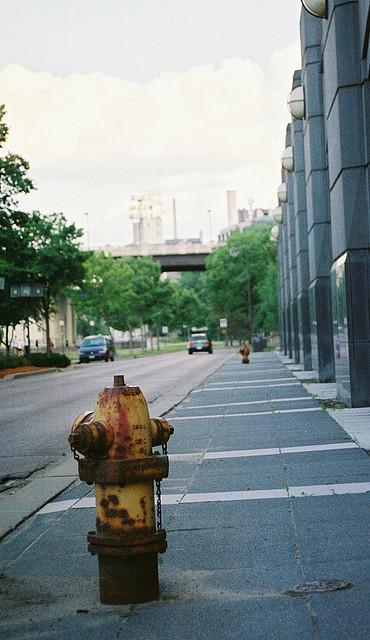How many cars are pictured?
Give a very brief answer. 2. 